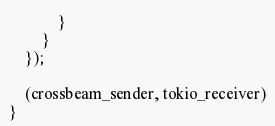<code> <loc_0><loc_0><loc_500><loc_500><_Rust_>            }
        }
    });

    (crossbeam_sender, tokio_receiver)
}
</code> 